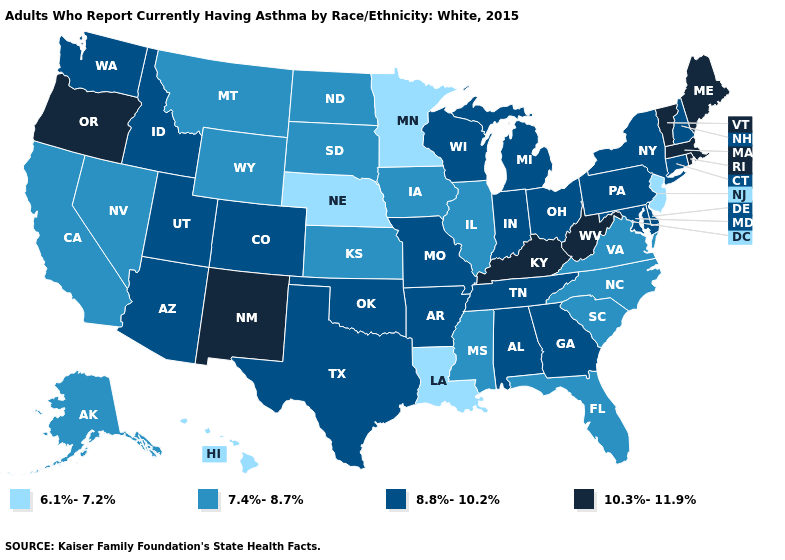Name the states that have a value in the range 6.1%-7.2%?
Be succinct. Hawaii, Louisiana, Minnesota, Nebraska, New Jersey. Does New Mexico have the highest value in the USA?
Quick response, please. Yes. Does the map have missing data?
Concise answer only. No. Which states have the lowest value in the MidWest?
Write a very short answer. Minnesota, Nebraska. What is the value of Wisconsin?
Give a very brief answer. 8.8%-10.2%. What is the highest value in the MidWest ?
Write a very short answer. 8.8%-10.2%. Does Montana have the lowest value in the USA?
Be succinct. No. Does the first symbol in the legend represent the smallest category?
Short answer required. Yes. Does the map have missing data?
Concise answer only. No. Which states have the lowest value in the Northeast?
Short answer required. New Jersey. What is the value of Delaware?
Answer briefly. 8.8%-10.2%. Does Kentucky have the highest value in the South?
Keep it brief. Yes. Name the states that have a value in the range 7.4%-8.7%?
Give a very brief answer. Alaska, California, Florida, Illinois, Iowa, Kansas, Mississippi, Montana, Nevada, North Carolina, North Dakota, South Carolina, South Dakota, Virginia, Wyoming. Is the legend a continuous bar?
Answer briefly. No. What is the value of New Jersey?
Short answer required. 6.1%-7.2%. 